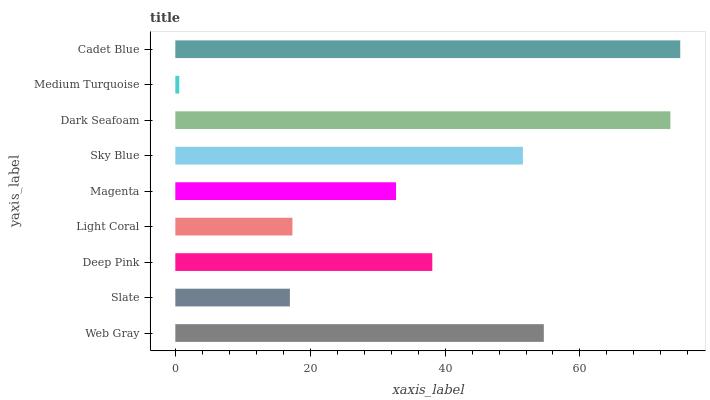Is Medium Turquoise the minimum?
Answer yes or no. Yes. Is Cadet Blue the maximum?
Answer yes or no. Yes. Is Slate the minimum?
Answer yes or no. No. Is Slate the maximum?
Answer yes or no. No. Is Web Gray greater than Slate?
Answer yes or no. Yes. Is Slate less than Web Gray?
Answer yes or no. Yes. Is Slate greater than Web Gray?
Answer yes or no. No. Is Web Gray less than Slate?
Answer yes or no. No. Is Deep Pink the high median?
Answer yes or no. Yes. Is Deep Pink the low median?
Answer yes or no. Yes. Is Light Coral the high median?
Answer yes or no. No. Is Dark Seafoam the low median?
Answer yes or no. No. 